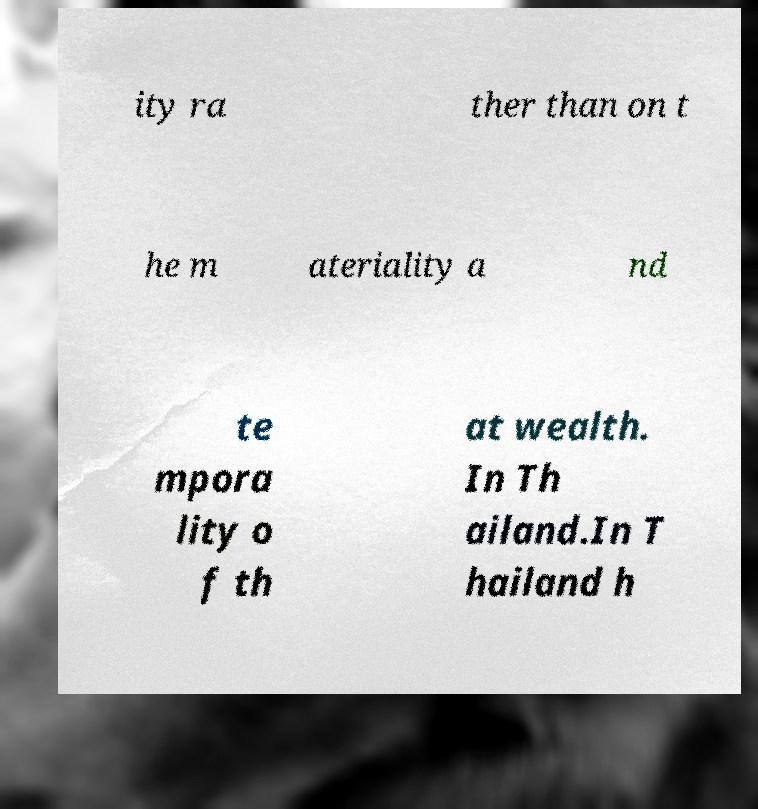I need the written content from this picture converted into text. Can you do that? ity ra ther than on t he m ateriality a nd te mpora lity o f th at wealth. In Th ailand.In T hailand h 